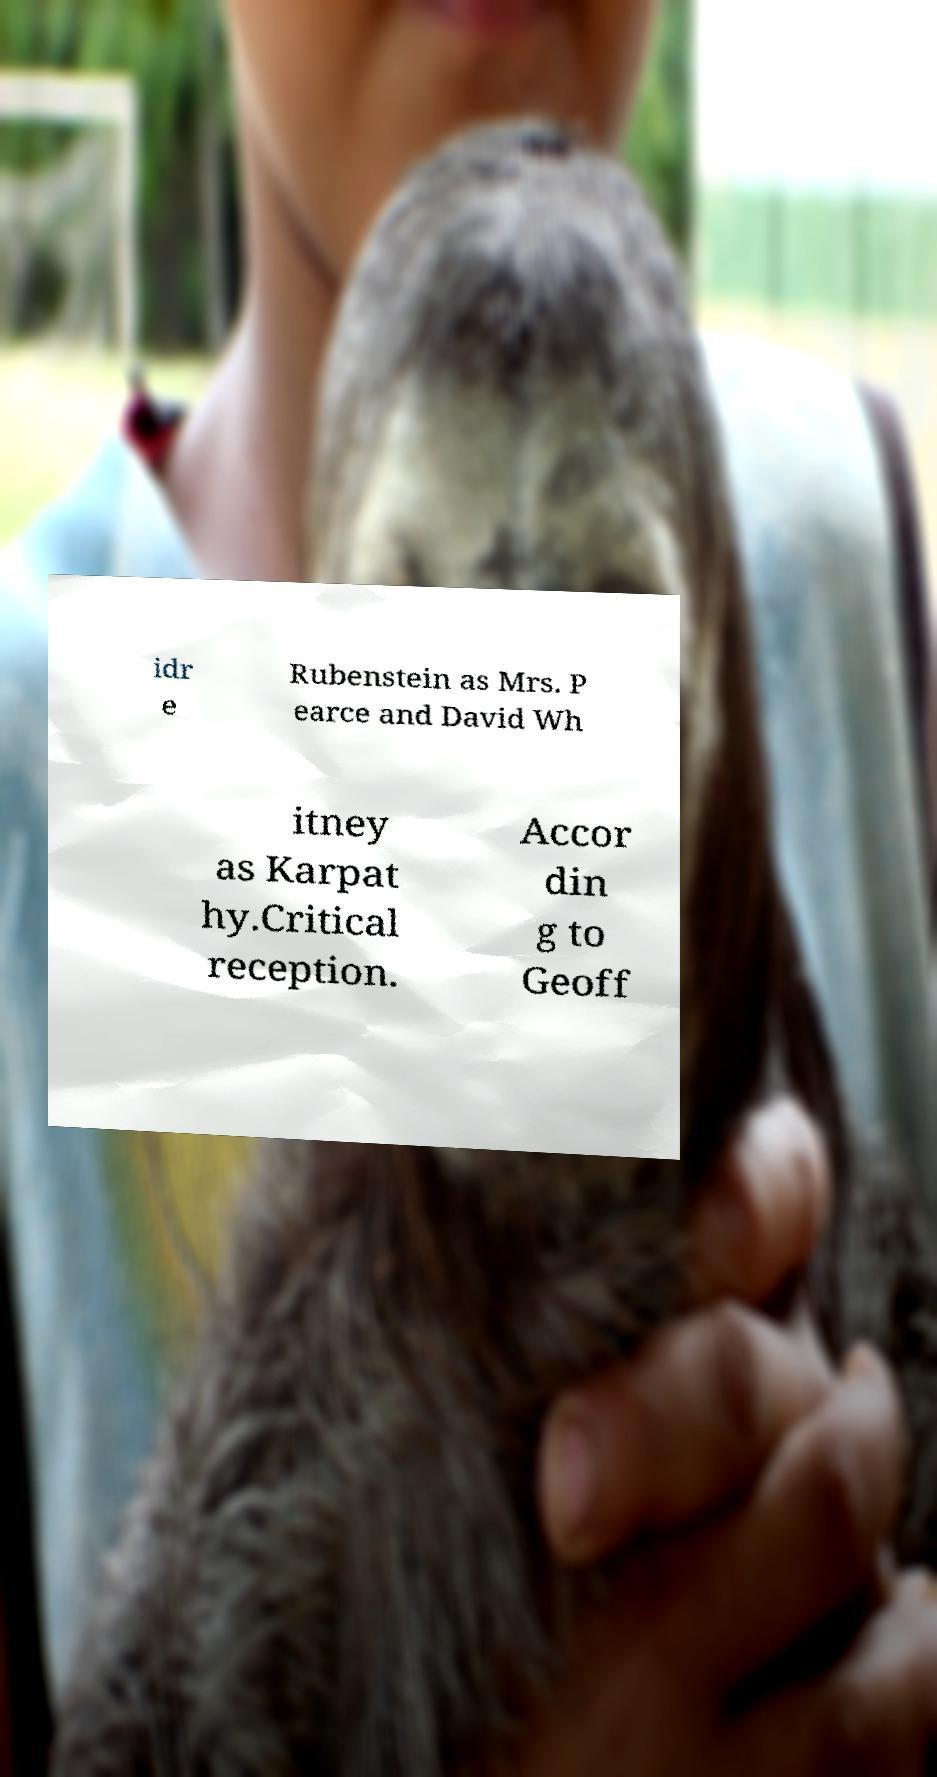Can you accurately transcribe the text from the provided image for me? idr e Rubenstein as Mrs. P earce and David Wh itney as Karpat hy.Critical reception. Accor din g to Geoff 